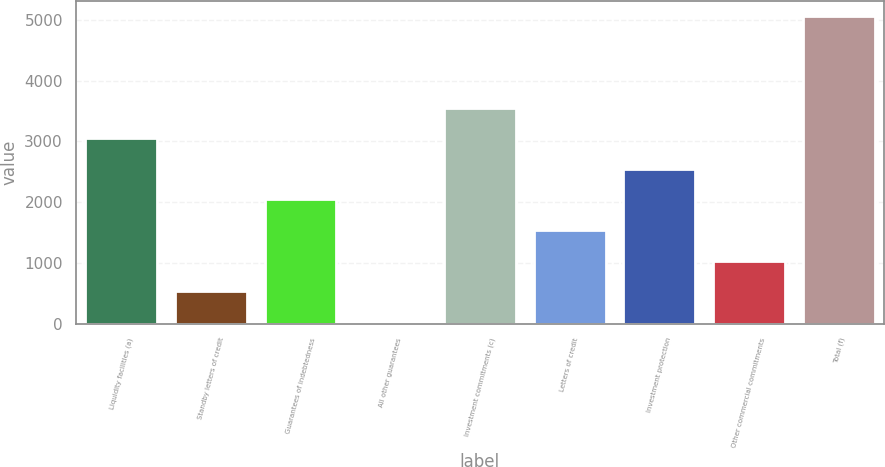<chart> <loc_0><loc_0><loc_500><loc_500><bar_chart><fcel>Liquidity facilities (a)<fcel>Standby letters of credit<fcel>Guarantees of indebtedness<fcel>All other guarantees<fcel>Investment commitments (c)<fcel>Letters of credit<fcel>Investment protection<fcel>Other commercial commitments<fcel>Total (f)<nl><fcel>3048.2<fcel>537.2<fcel>2043.8<fcel>35<fcel>3550.4<fcel>1541.6<fcel>2546<fcel>1039.4<fcel>5057<nl></chart> 